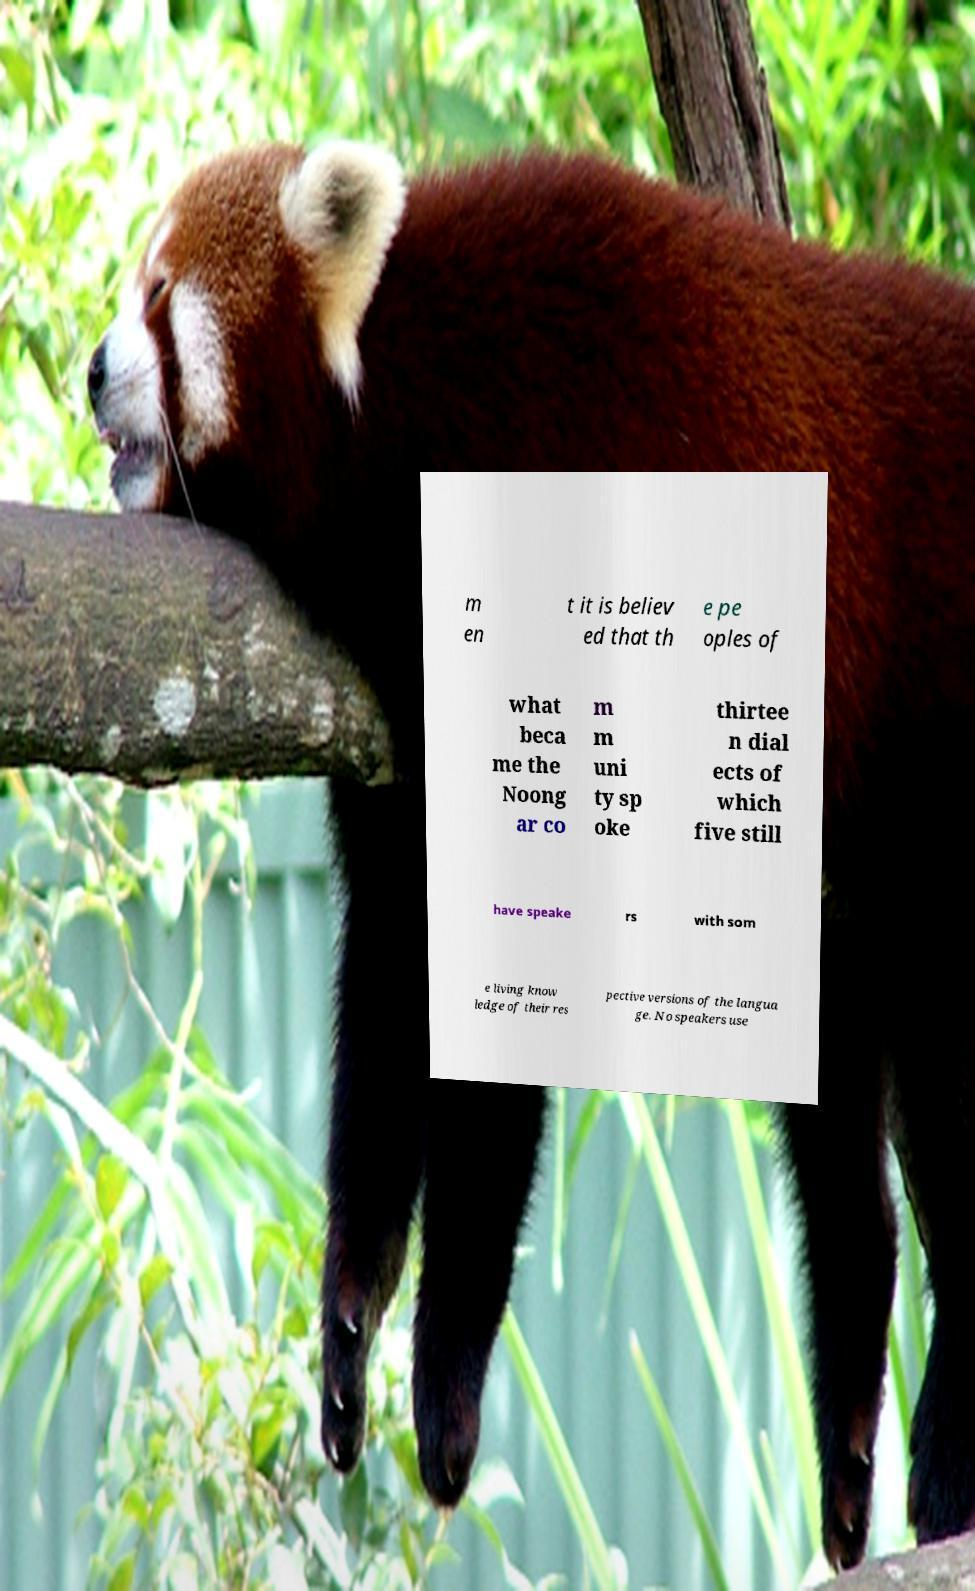I need the written content from this picture converted into text. Can you do that? m en t it is believ ed that th e pe oples of what beca me the Noong ar co m m uni ty sp oke thirtee n dial ects of which five still have speake rs with som e living know ledge of their res pective versions of the langua ge. No speakers use 